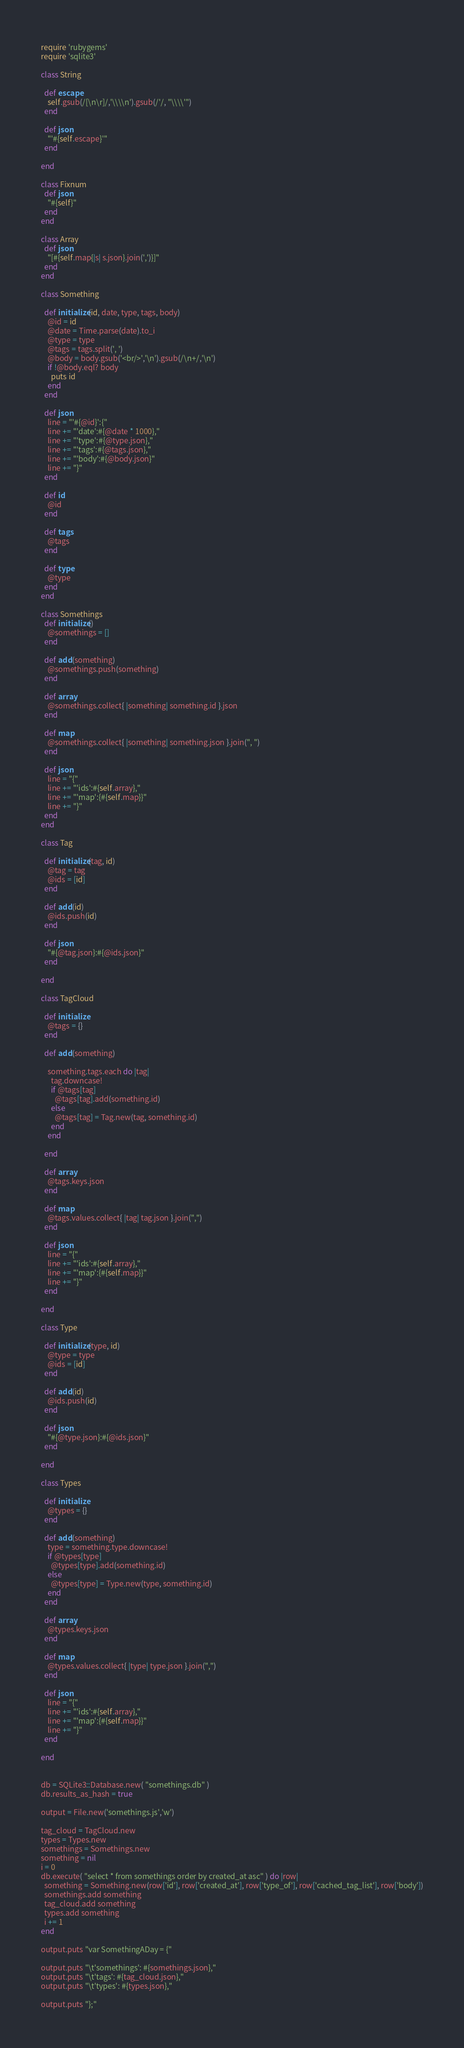Convert code to text. <code><loc_0><loc_0><loc_500><loc_500><_Ruby_>require 'rubygems'
require 'sqlite3'

class String
  
  def escape
    self.gsub(/[\n\r]/,'\\\\n').gsub(/'/, "\\\\'")
  end
  
  def json
    "'#{self.escape}'"
  end
  
end

class Fixnum
  def json
    "#{self}"
  end
end

class Array
  def json
    "[#{self.map{|s| s.json}.join(',')}]"
  end
end

class Something
  
  def initialize(id, date, type, tags, body)
    @id = id
    @date = Time.parse(date).to_i
    @type = type
    @tags = tags.split(', ')
    @body = body.gsub('<br/>','\n').gsub(/\n+/,'\n')
    if !@body.eql? body
      puts id
    end
  end
  
  def json
    line = "'#{@id}':{"
    line += "'date':#{@date * 1000},"
    line += "'type':#{@type.json},"
    line += "'tags':#{@tags.json},"
    line += "'body':#{@body.json}"
    line += "}"
  end
  
  def id
    @id
  end
  
  def tags
    @tags
  end
  
  def type
    @type
  end
end

class Somethings
  def initialize()
    @somethings = []
  end
  
  def add(something)
    @somethings.push(something)
  end
  
  def array
    @somethings.collect{ |something| something.id }.json
  end
  
  def map
    @somethings.collect{ |something| something.json }.join(", ")
  end
  
  def json
    line = "{"
    line += "'ids':#{self.array},"
    line += "'map':{#{self.map}}"
    line += "}"
  end
end

class Tag
  
  def initialize(tag, id)
    @tag = tag
    @ids = [id]
  end
  
  def add(id)
    @ids.push(id)
  end
  
  def json
    "#{@tag.json}:#{@ids.json}"
  end
  
end

class TagCloud
  
  def initialize
    @tags = {}
  end
  
  def add(something)
    
    something.tags.each do |tag|
      tag.downcase!
      if @tags[tag]
        @tags[tag].add(something.id)
      else
        @tags[tag] = Tag.new(tag, something.id)
      end
    end
    
  end
  
  def array
    @tags.keys.json
  end
  
  def map
    @tags.values.collect{ |tag| tag.json }.join(",")
  end
  
  def json
    line = "{"
    line += "'ids':#{self.array},"
    line += "'map':{#{self.map}}"
    line += "}"
  end
  
end

class Type
  
  def initialize(type, id)
    @type = type
    @ids = [id]
  end
  
  def add(id)
    @ids.push(id)
  end
  
  def json
    "#{@type.json}:#{@ids.json}"
  end
  
end

class Types
  
  def initialize
    @types = {}
  end
  
  def add(something)
    type = something.type.downcase!
    if @types[type]
      @types[type].add(something.id)
    else
      @types[type] = Type.new(type, something.id)
    end
  end
  
  def array
    @types.keys.json
  end
  
  def map
    @types.values.collect{ |type| type.json }.join(",")
  end
  
  def json
    line = "{"
    line += "'ids':#{self.array},"
    line += "'map':{#{self.map}}"
    line += "}"
  end
  
end


db = SQLite3::Database.new( "somethings.db" )
db.results_as_hash = true

output = File.new('somethings.js','w')

tag_cloud = TagCloud.new
types = Types.new
somethings = Somethings.new
something = nil
i = 0
db.execute( "select * from somethings order by created_at asc" ) do |row|
  something = Something.new(row['id'], row['created_at'], row['type_of'], row['cached_tag_list'], row['body'])
  somethings.add something
  tag_cloud.add something
  types.add something
  i += 1
end

output.puts "var SomethingADay = {"

output.puts "\t'somethings': #{somethings.json},"
output.puts "\t'tags': #{tag_cloud.json},"
output.puts "\t'types': #{types.json},"

output.puts "};"
</code> 